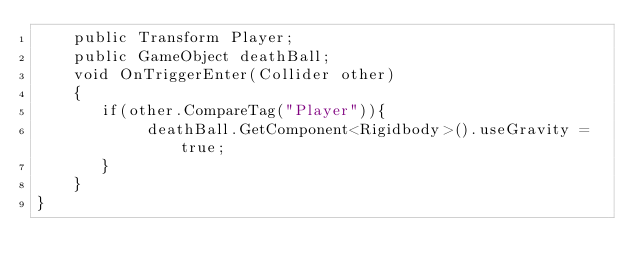Convert code to text. <code><loc_0><loc_0><loc_500><loc_500><_C#_>    public Transform Player;
    public GameObject deathBall;
    void OnTriggerEnter(Collider other)
    {
       if(other.CompareTag("Player")){
            deathBall.GetComponent<Rigidbody>().useGravity = true;
       }
    }
}



</code> 